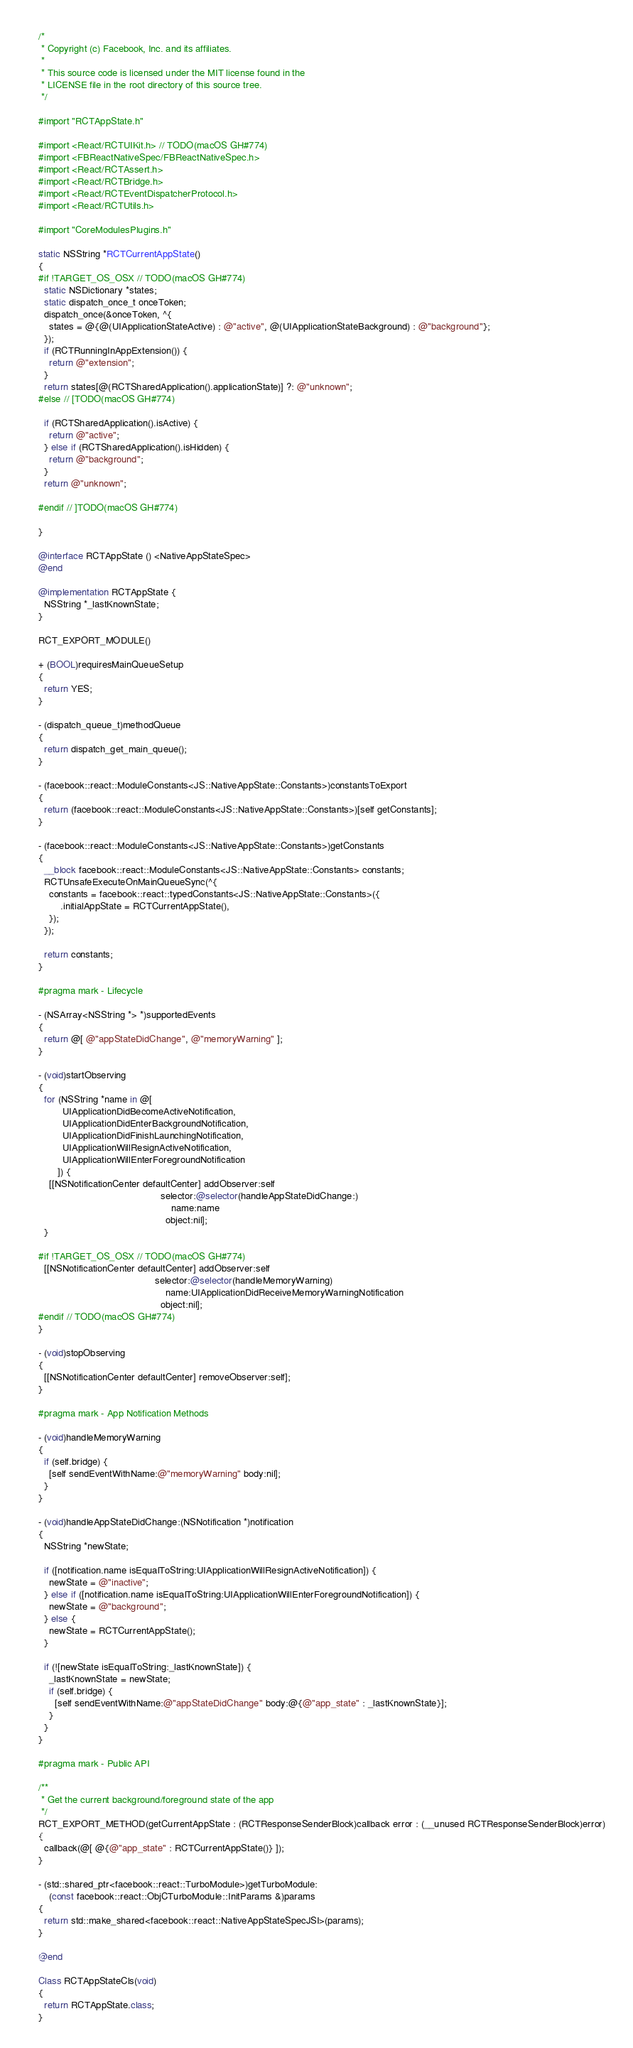Convert code to text. <code><loc_0><loc_0><loc_500><loc_500><_ObjectiveC_>/*
 * Copyright (c) Facebook, Inc. and its affiliates.
 *
 * This source code is licensed under the MIT license found in the
 * LICENSE file in the root directory of this source tree.
 */

#import "RCTAppState.h"

#import <React/RCTUIKit.h> // TODO(macOS GH#774)
#import <FBReactNativeSpec/FBReactNativeSpec.h>
#import <React/RCTAssert.h>
#import <React/RCTBridge.h>
#import <React/RCTEventDispatcherProtocol.h>
#import <React/RCTUtils.h>

#import "CoreModulesPlugins.h"

static NSString *RCTCurrentAppState()
{
#if !TARGET_OS_OSX // TODO(macOS GH#774)
  static NSDictionary *states;
  static dispatch_once_t onceToken;
  dispatch_once(&onceToken, ^{
    states = @{@(UIApplicationStateActive) : @"active", @(UIApplicationStateBackground) : @"background"};
  });
  if (RCTRunningInAppExtension()) {
    return @"extension";
  }
  return states[@(RCTSharedApplication().applicationState)] ?: @"unknown";
#else // [TODO(macOS GH#774)
  
  if (RCTSharedApplication().isActive) {
    return @"active";
  } else if (RCTSharedApplication().isHidden) {
    return @"background";
  }
  return @"unknown";
  
#endif // ]TODO(macOS GH#774)
  
}

@interface RCTAppState () <NativeAppStateSpec>
@end

@implementation RCTAppState {
  NSString *_lastKnownState;
}

RCT_EXPORT_MODULE()

+ (BOOL)requiresMainQueueSetup
{
  return YES;
}

- (dispatch_queue_t)methodQueue
{
  return dispatch_get_main_queue();
}

- (facebook::react::ModuleConstants<JS::NativeAppState::Constants>)constantsToExport
{
  return (facebook::react::ModuleConstants<JS::NativeAppState::Constants>)[self getConstants];
}

- (facebook::react::ModuleConstants<JS::NativeAppState::Constants>)getConstants
{
  __block facebook::react::ModuleConstants<JS::NativeAppState::Constants> constants;
  RCTUnsafeExecuteOnMainQueueSync(^{
    constants = facebook::react::typedConstants<JS::NativeAppState::Constants>({
        .initialAppState = RCTCurrentAppState(),
    });
  });

  return constants;
}

#pragma mark - Lifecycle

- (NSArray<NSString *> *)supportedEvents
{
  return @[ @"appStateDidChange", @"memoryWarning" ];
}

- (void)startObserving
{
  for (NSString *name in @[
         UIApplicationDidBecomeActiveNotification,
         UIApplicationDidEnterBackgroundNotification,
         UIApplicationDidFinishLaunchingNotification,
         UIApplicationWillResignActiveNotification,
         UIApplicationWillEnterForegroundNotification
       ]) {
    [[NSNotificationCenter defaultCenter] addObserver:self
                                             selector:@selector(handleAppStateDidChange:)
                                                 name:name
                                               object:nil];
  }

#if !TARGET_OS_OSX // TODO(macOS GH#774)
  [[NSNotificationCenter defaultCenter] addObserver:self
                                           selector:@selector(handleMemoryWarning)
                                               name:UIApplicationDidReceiveMemoryWarningNotification
                                             object:nil];
#endif // TODO(macOS GH#774)
}

- (void)stopObserving
{
  [[NSNotificationCenter defaultCenter] removeObserver:self];
}

#pragma mark - App Notification Methods

- (void)handleMemoryWarning
{
  if (self.bridge) {
    [self sendEventWithName:@"memoryWarning" body:nil];
  }
}

- (void)handleAppStateDidChange:(NSNotification *)notification
{
  NSString *newState;

  if ([notification.name isEqualToString:UIApplicationWillResignActiveNotification]) {
    newState = @"inactive";
  } else if ([notification.name isEqualToString:UIApplicationWillEnterForegroundNotification]) {
    newState = @"background";
  } else {
    newState = RCTCurrentAppState();
  }

  if (![newState isEqualToString:_lastKnownState]) {
    _lastKnownState = newState;
    if (self.bridge) {
      [self sendEventWithName:@"appStateDidChange" body:@{@"app_state" : _lastKnownState}];
    }
  }
}

#pragma mark - Public API

/**
 * Get the current background/foreground state of the app
 */
RCT_EXPORT_METHOD(getCurrentAppState : (RCTResponseSenderBlock)callback error : (__unused RCTResponseSenderBlock)error)
{
  callback(@[ @{@"app_state" : RCTCurrentAppState()} ]);
}

- (std::shared_ptr<facebook::react::TurboModule>)getTurboModule:
    (const facebook::react::ObjCTurboModule::InitParams &)params
{
  return std::make_shared<facebook::react::NativeAppStateSpecJSI>(params);
}

@end

Class RCTAppStateCls(void)
{
  return RCTAppState.class;
}
</code> 